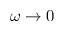<formula> <loc_0><loc_0><loc_500><loc_500>\omega \to 0</formula> 